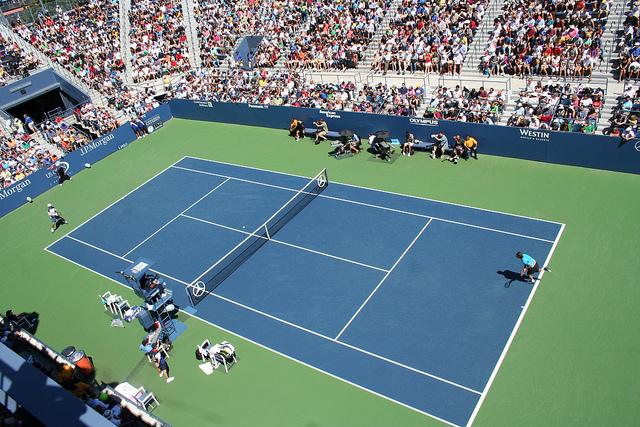Are there people in the stands?
Keep it brief. Yes. Is there an opponent?
Keep it brief. Yes. How many people are on the court?
Keep it brief. 2. What is the sport?
Write a very short answer. Tennis. How many people in the shot?
Short answer required. 1000. 